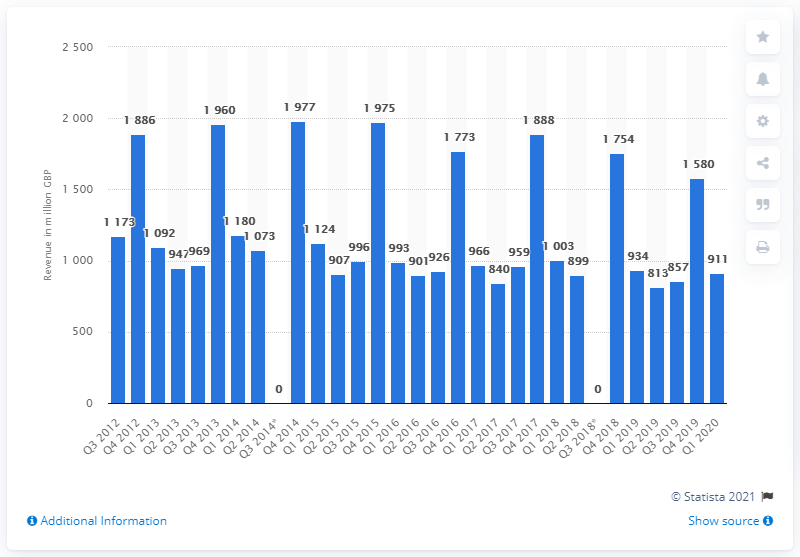List a handful of essential elements in this visual. The Consumer Electronics division generated $911 million in revenue during the first quarter of 2020. 